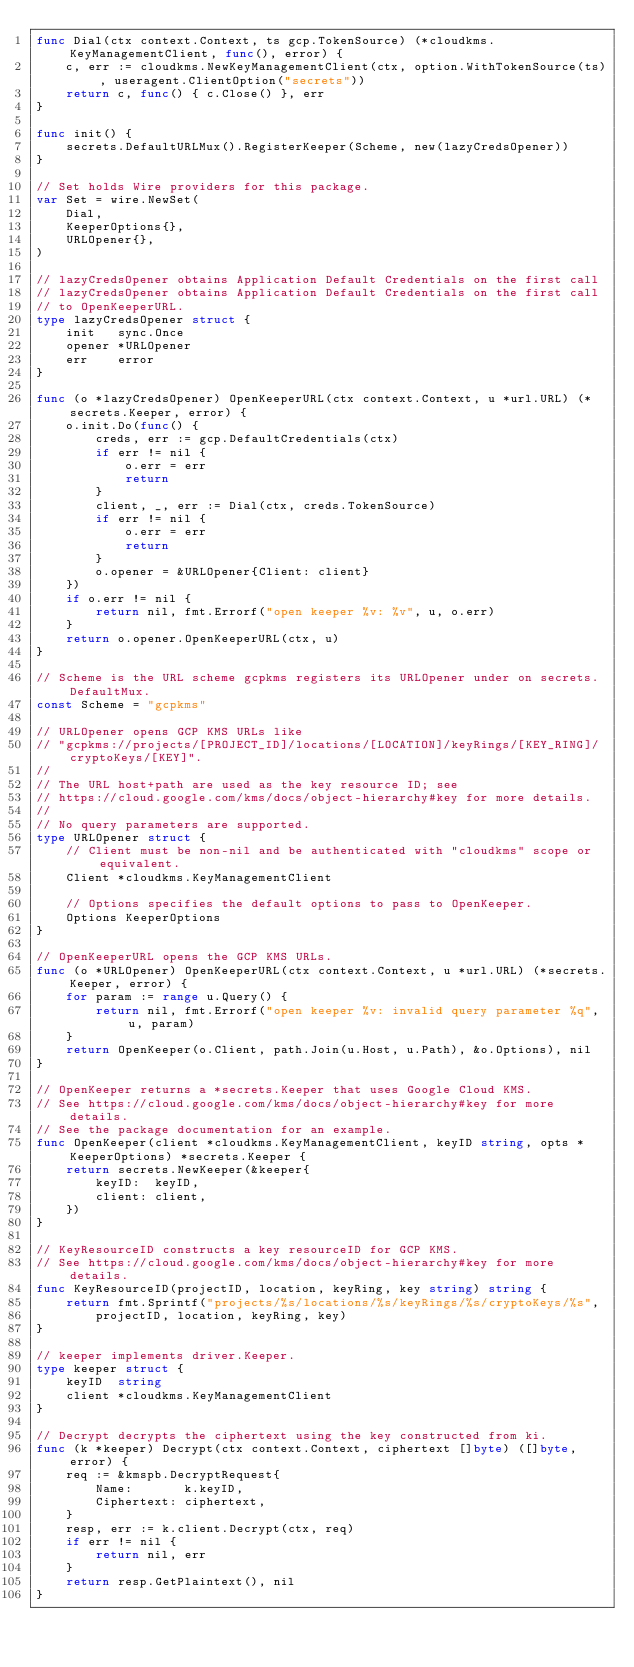<code> <loc_0><loc_0><loc_500><loc_500><_Go_>func Dial(ctx context.Context, ts gcp.TokenSource) (*cloudkms.KeyManagementClient, func(), error) {
	c, err := cloudkms.NewKeyManagementClient(ctx, option.WithTokenSource(ts), useragent.ClientOption("secrets"))
	return c, func() { c.Close() }, err
}

func init() {
	secrets.DefaultURLMux().RegisterKeeper(Scheme, new(lazyCredsOpener))
}

// Set holds Wire providers for this package.
var Set = wire.NewSet(
	Dial,
	KeeperOptions{},
	URLOpener{},
)

// lazyCredsOpener obtains Application Default Credentials on the first call
// lazyCredsOpener obtains Application Default Credentials on the first call
// to OpenKeeperURL.
type lazyCredsOpener struct {
	init   sync.Once
	opener *URLOpener
	err    error
}

func (o *lazyCredsOpener) OpenKeeperURL(ctx context.Context, u *url.URL) (*secrets.Keeper, error) {
	o.init.Do(func() {
		creds, err := gcp.DefaultCredentials(ctx)
		if err != nil {
			o.err = err
			return
		}
		client, _, err := Dial(ctx, creds.TokenSource)
		if err != nil {
			o.err = err
			return
		}
		o.opener = &URLOpener{Client: client}
	})
	if o.err != nil {
		return nil, fmt.Errorf("open keeper %v: %v", u, o.err)
	}
	return o.opener.OpenKeeperURL(ctx, u)
}

// Scheme is the URL scheme gcpkms registers its URLOpener under on secrets.DefaultMux.
const Scheme = "gcpkms"

// URLOpener opens GCP KMS URLs like
// "gcpkms://projects/[PROJECT_ID]/locations/[LOCATION]/keyRings/[KEY_RING]/cryptoKeys/[KEY]".
//
// The URL host+path are used as the key resource ID; see
// https://cloud.google.com/kms/docs/object-hierarchy#key for more details.
//
// No query parameters are supported.
type URLOpener struct {
	// Client must be non-nil and be authenticated with "cloudkms" scope or equivalent.
	Client *cloudkms.KeyManagementClient

	// Options specifies the default options to pass to OpenKeeper.
	Options KeeperOptions
}

// OpenKeeperURL opens the GCP KMS URLs.
func (o *URLOpener) OpenKeeperURL(ctx context.Context, u *url.URL) (*secrets.Keeper, error) {
	for param := range u.Query() {
		return nil, fmt.Errorf("open keeper %v: invalid query parameter %q", u, param)
	}
	return OpenKeeper(o.Client, path.Join(u.Host, u.Path), &o.Options), nil
}

// OpenKeeper returns a *secrets.Keeper that uses Google Cloud KMS.
// See https://cloud.google.com/kms/docs/object-hierarchy#key for more details.
// See the package documentation for an example.
func OpenKeeper(client *cloudkms.KeyManagementClient, keyID string, opts *KeeperOptions) *secrets.Keeper {
	return secrets.NewKeeper(&keeper{
		keyID:  keyID,
		client: client,
	})
}

// KeyResourceID constructs a key resourceID for GCP KMS.
// See https://cloud.google.com/kms/docs/object-hierarchy#key for more details.
func KeyResourceID(projectID, location, keyRing, key string) string {
	return fmt.Sprintf("projects/%s/locations/%s/keyRings/%s/cryptoKeys/%s",
		projectID, location, keyRing, key)
}

// keeper implements driver.Keeper.
type keeper struct {
	keyID  string
	client *cloudkms.KeyManagementClient
}

// Decrypt decrypts the ciphertext using the key constructed from ki.
func (k *keeper) Decrypt(ctx context.Context, ciphertext []byte) ([]byte, error) {
	req := &kmspb.DecryptRequest{
		Name:       k.keyID,
		Ciphertext: ciphertext,
	}
	resp, err := k.client.Decrypt(ctx, req)
	if err != nil {
		return nil, err
	}
	return resp.GetPlaintext(), nil
}
</code> 